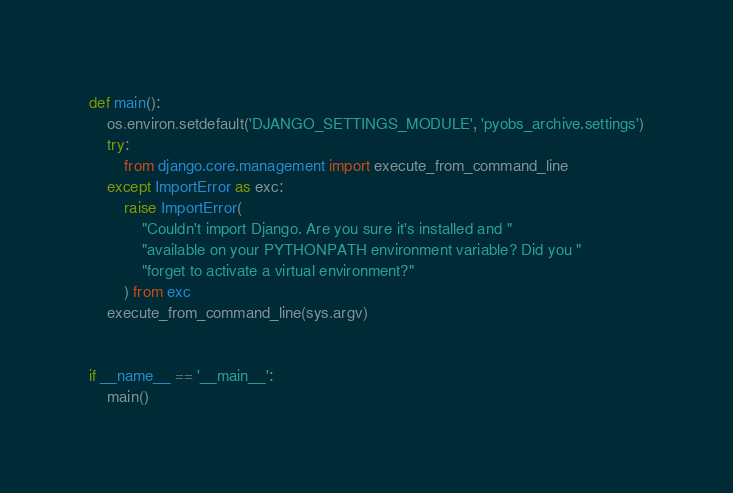<code> <loc_0><loc_0><loc_500><loc_500><_Python_>def main():
    os.environ.setdefault('DJANGO_SETTINGS_MODULE', 'pyobs_archive.settings')
    try:
        from django.core.management import execute_from_command_line
    except ImportError as exc:
        raise ImportError(
            "Couldn't import Django. Are you sure it's installed and "
            "available on your PYTHONPATH environment variable? Did you "
            "forget to activate a virtual environment?"
        ) from exc
    execute_from_command_line(sys.argv)


if __name__ == '__main__':
    main()
</code> 